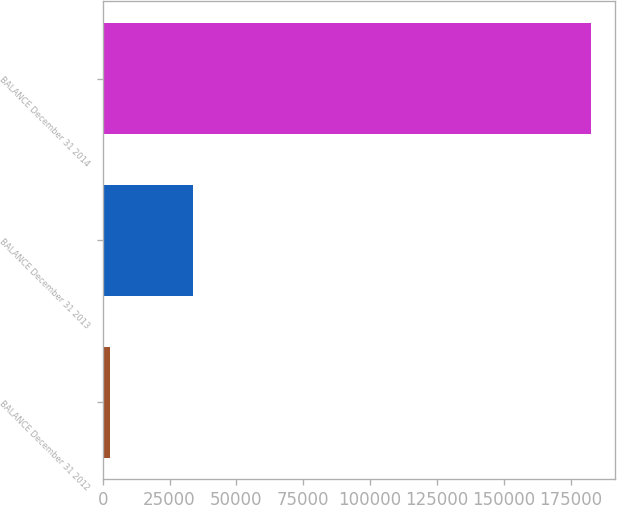Convert chart to OTSL. <chart><loc_0><loc_0><loc_500><loc_500><bar_chart><fcel>BALANCE December 31 2012<fcel>BALANCE December 31 2013<fcel>BALANCE December 31 2014<nl><fcel>2791<fcel>33679<fcel>182486<nl></chart> 